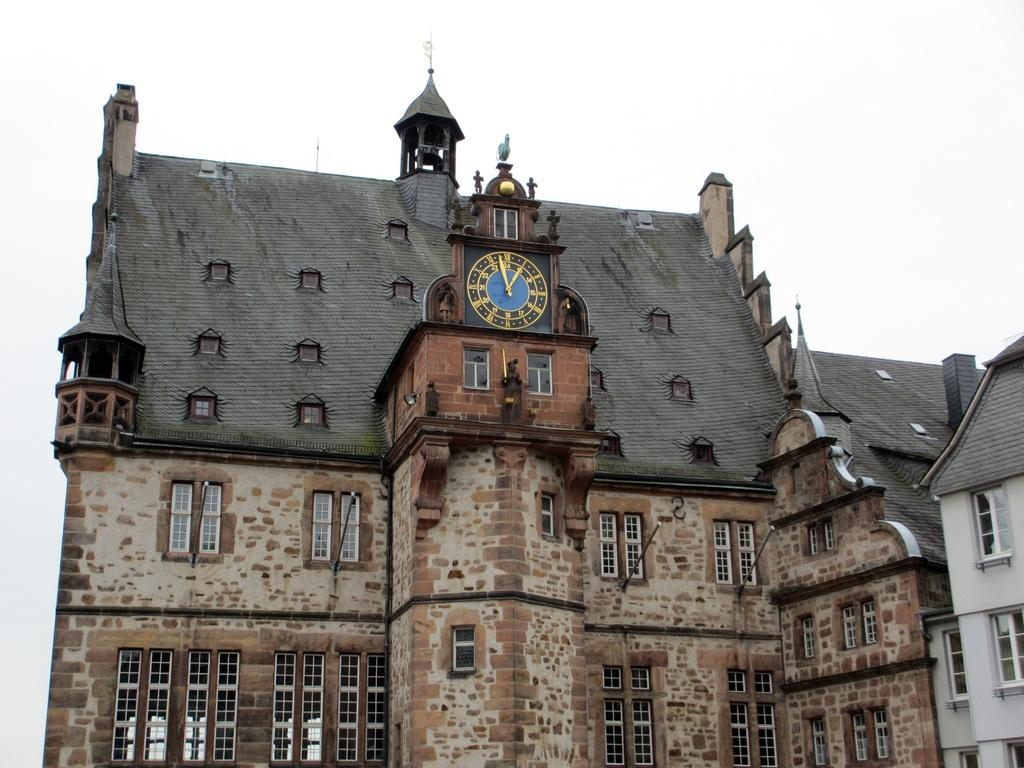What type of structures are present in the image? There are buildings with windows in the image. Can you describe any specific features on the buildings? Yes, there is a clock on one of the buildings and statues on the buildings. What can be seen in the background of the image? The sky is visible in the background of the image. How does the cow contribute to the comfort of the people in the image? There are no cows present in the image, so it is not possible to determine how a cow might contribute to the comfort of the people. 